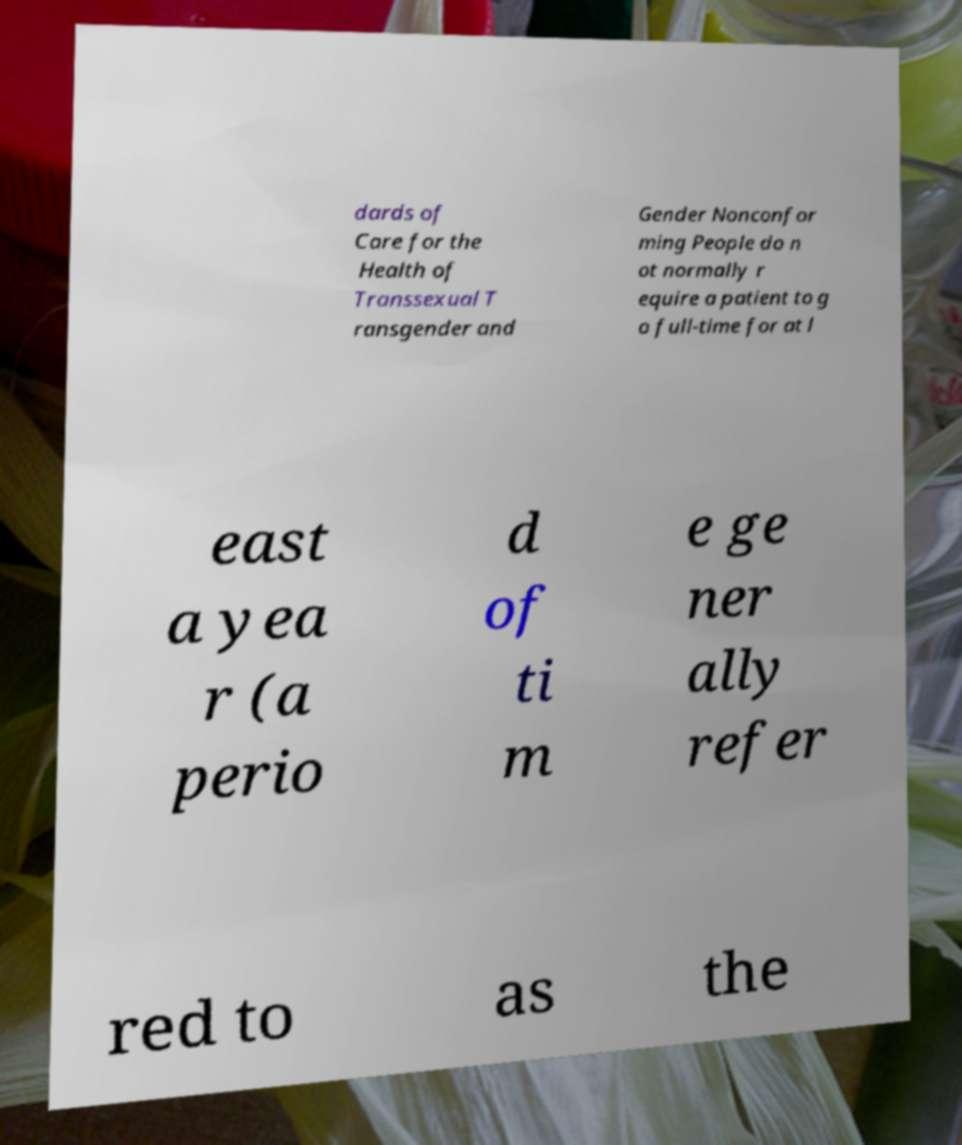Can you read and provide the text displayed in the image?This photo seems to have some interesting text. Can you extract and type it out for me? dards of Care for the Health of Transsexual T ransgender and Gender Nonconfor ming People do n ot normally r equire a patient to g o full-time for at l east a yea r (a perio d of ti m e ge ner ally refer red to as the 